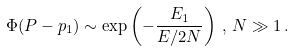Convert formula to latex. <formula><loc_0><loc_0><loc_500><loc_500>\Phi ( P - p _ { 1 } ) \sim \exp \left ( - \frac { E _ { 1 } } { E / 2 N } \right ) \, , \, N \gg 1 \, .</formula> 